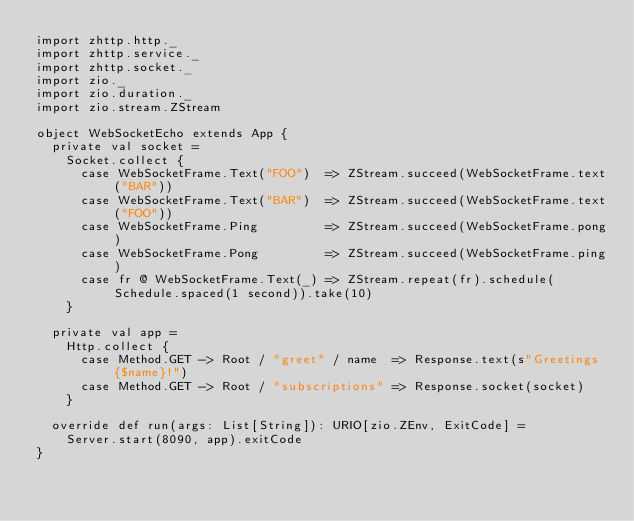Convert code to text. <code><loc_0><loc_0><loc_500><loc_500><_Scala_>import zhttp.http._
import zhttp.service._
import zhttp.socket._
import zio._
import zio.duration._
import zio.stream.ZStream

object WebSocketEcho extends App {
  private val socket =
    Socket.collect {
      case WebSocketFrame.Text("FOO")  => ZStream.succeed(WebSocketFrame.text("BAR"))
      case WebSocketFrame.Text("BAR")  => ZStream.succeed(WebSocketFrame.text("FOO"))
      case WebSocketFrame.Ping         => ZStream.succeed(WebSocketFrame.pong)
      case WebSocketFrame.Pong         => ZStream.succeed(WebSocketFrame.ping)
      case fr @ WebSocketFrame.Text(_) => ZStream.repeat(fr).schedule(Schedule.spaced(1 second)).take(10)
    }

  private val app =
    Http.collect {
      case Method.GET -> Root / "greet" / name  => Response.text(s"Greetings {$name}!")
      case Method.GET -> Root / "subscriptions" => Response.socket(socket)
    }

  override def run(args: List[String]): URIO[zio.ZEnv, ExitCode] =
    Server.start(8090, app).exitCode
}
</code> 